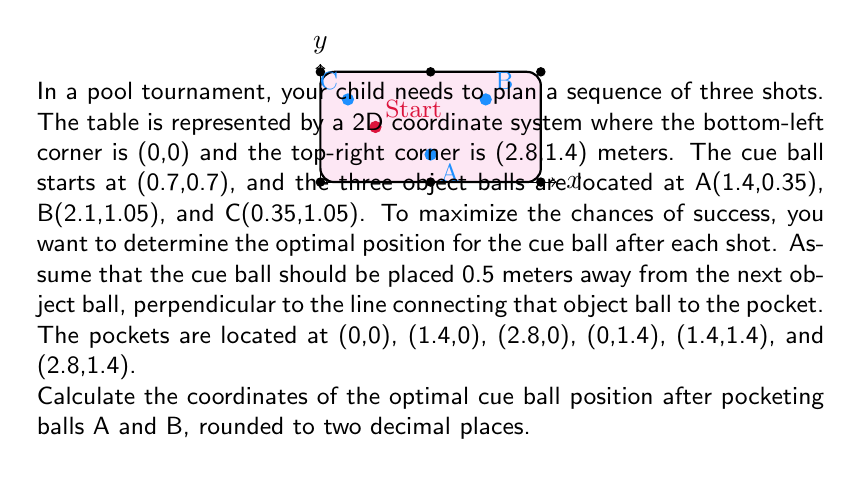Solve this math problem. Let's approach this step-by-step:

1) First, we need to determine which pocket each ball should be aimed at. 
   - Ball A is closest to the middle-bottom pocket (1.4,0)
   - Ball B is closest to the top-right pocket (2.8,1.4)
   - Ball C is closest to the top-left pocket (0,1.4)

2) For ball A:
   - The line from A to the pocket is $y = \frac{0-0.35}{1.4-1.4}(x-1.4) + 0.35 = 0.35$
   - The perpendicular line at A is $y = -\frac{1.4-1.4}{0-0.35}(x-1.4) + 0.35 = -4(x-1.4) + 0.35$
   - We need a point 0.5m away from A on this line. The general point is $(1.4 + t, -4t + 0.35)$
   - The distance should be 0.5: $\sqrt{t^2 + (-4t)^2} = 0.5$
   - Solving this: $t = \pm \frac{0.5}{\sqrt{17}}$
   - We choose the positive t as it's towards the center of the table
   - So, the optimal position after pocketing A is $(1.4 + \frac{0.5}{\sqrt{17}}, 0.35 - \frac{2}{\sqrt{17}})$

3) For ball B:
   - The line from B to the pocket is $y = \frac{1.4-1.05}{2.8-2.1}(x-2.1) + 1.05 = 0.5(x-2.1) + 1.05$
   - The perpendicular line at B is $y = -2(x-2.1) + 1.05$
   - The general point 0.5m away is $(2.1 + t, -2t + 1.05)$
   - Solving $\sqrt{t^2 + (-2t)^2} = 0.5$, we get $t = \pm \frac{0.5}{\sqrt{5}}$
   - We choose the negative t as it's towards the center of the table
   - So, the optimal position after pocketing B is $(2.1 - \frac{0.5}{\sqrt{5}}, 1.05 + \frac{1}{\sqrt{5}})$

4) Converting to decimal and rounding to two places:
   - After A: (1.52, 0.23)
   - After B: (1.88, 1.49)
Answer: (1.52, 0.23) and (1.88, 1.49) 